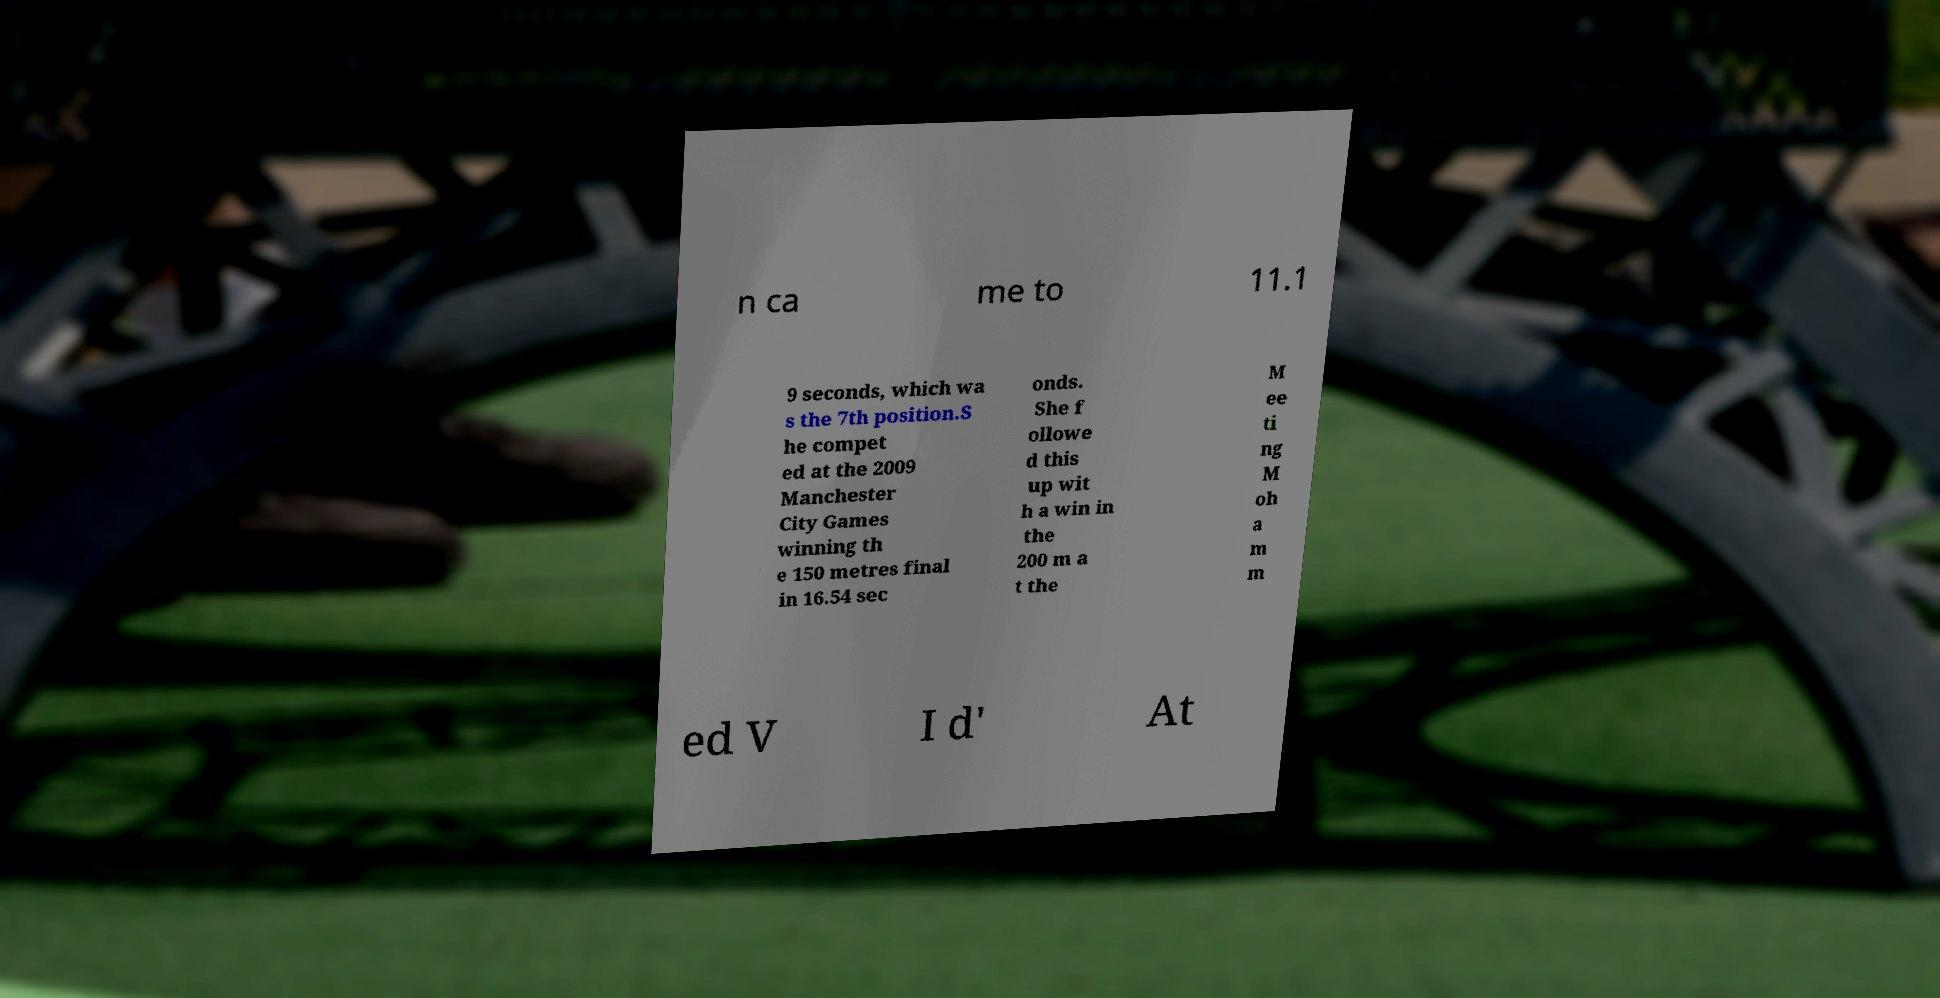Could you extract and type out the text from this image? n ca me to 11.1 9 seconds, which wa s the 7th position.S he compet ed at the 2009 Manchester City Games winning th e 150 metres final in 16.54 sec onds. She f ollowe d this up wit h a win in the 200 m a t the M ee ti ng M oh a m m ed V I d' At 